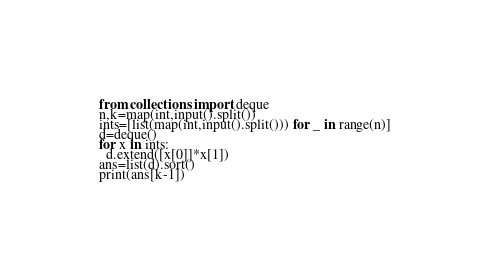<code> <loc_0><loc_0><loc_500><loc_500><_Python_>from collections import deque
n,k=map(int,input().split())
ints=[list(map(int,input().split())) for _ in range(n)]
d=deque()
for x in ints:
  d.extend([x[0]]*x[1])
ans=list(d).sort()
print(ans[k-1])</code> 